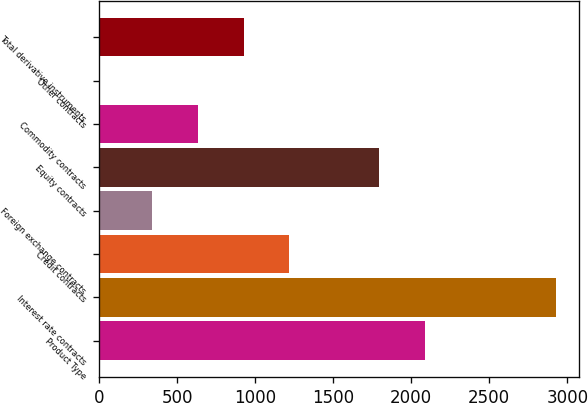Convert chart. <chart><loc_0><loc_0><loc_500><loc_500><bar_chart><fcel>Product Type<fcel>Interest rate contracts<fcel>Credit contracts<fcel>Foreign exchange contracts<fcel>Equity contracts<fcel>Commodity contracts<fcel>Other contracts<fcel>Total derivative instruments<nl><fcel>2086.9<fcel>2930<fcel>1218.7<fcel>340<fcel>1794<fcel>632.9<fcel>1<fcel>925.8<nl></chart> 